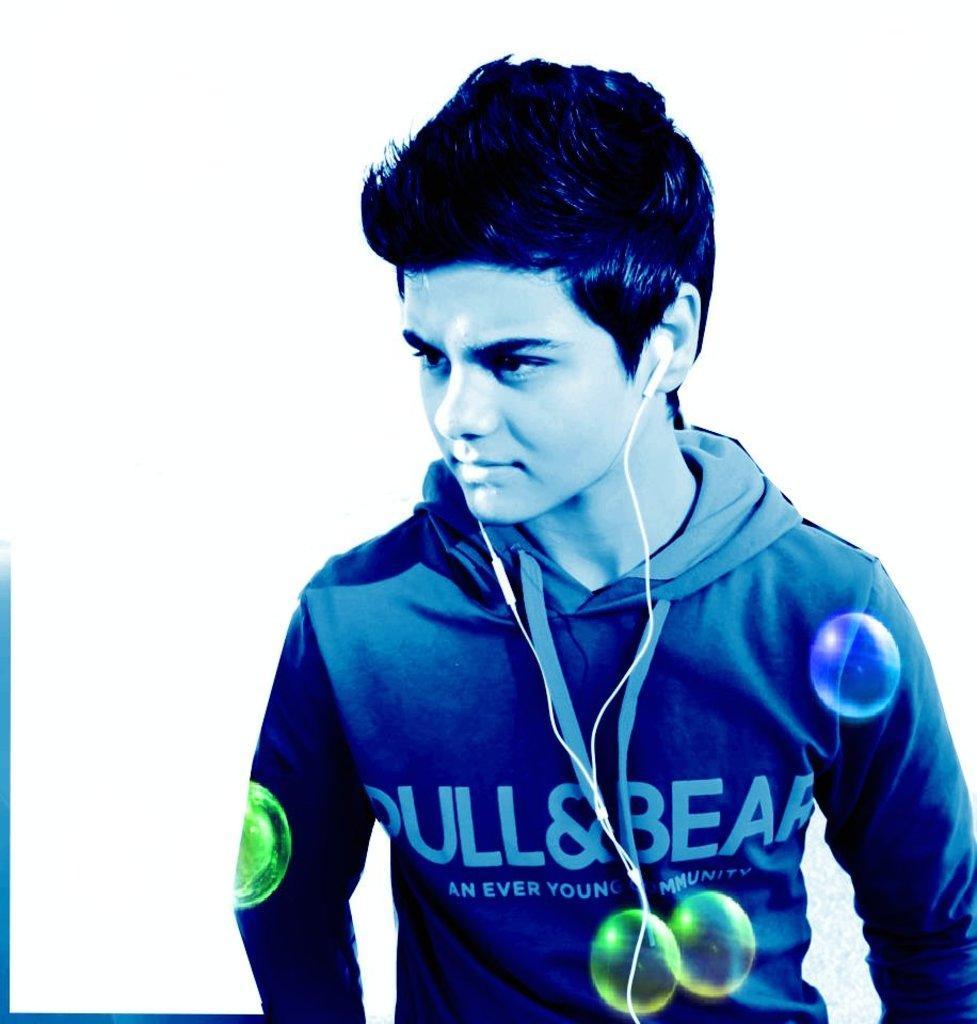Please provide a concise description of this image. The man in the blue jacket is standing. He is having an earphones in his ears. In the background, it is white in color. 